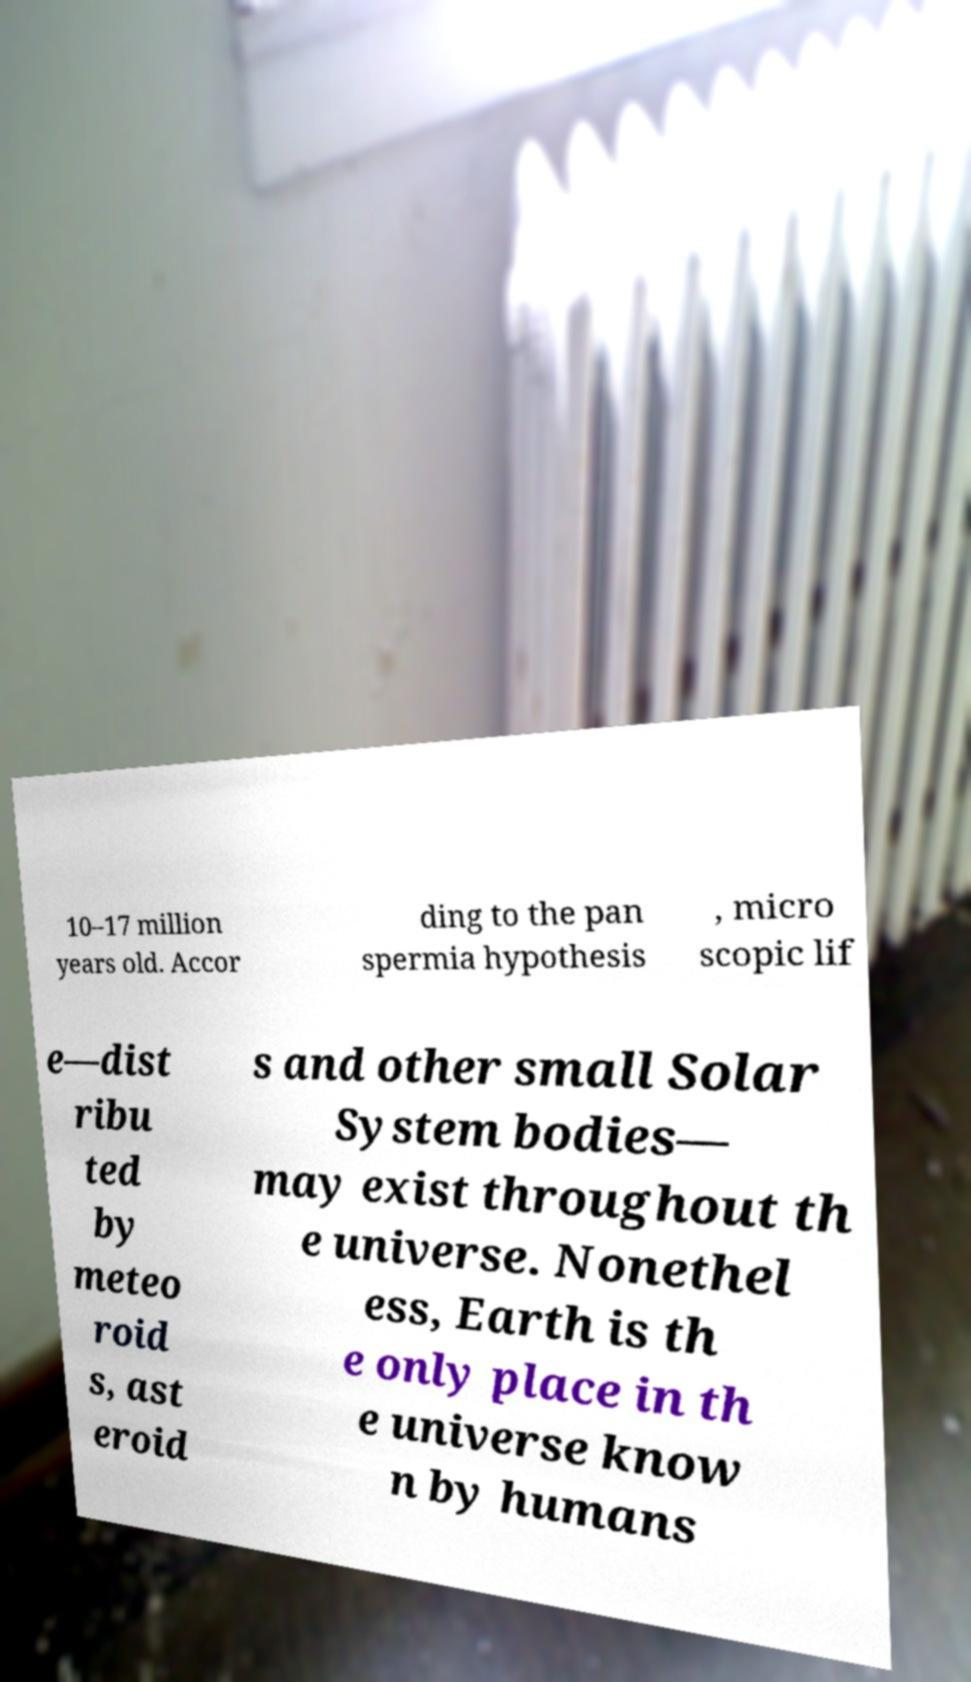Can you accurately transcribe the text from the provided image for me? 10–17 million years old. Accor ding to the pan spermia hypothesis , micro scopic lif e—dist ribu ted by meteo roid s, ast eroid s and other small Solar System bodies— may exist throughout th e universe. Nonethel ess, Earth is th e only place in th e universe know n by humans 